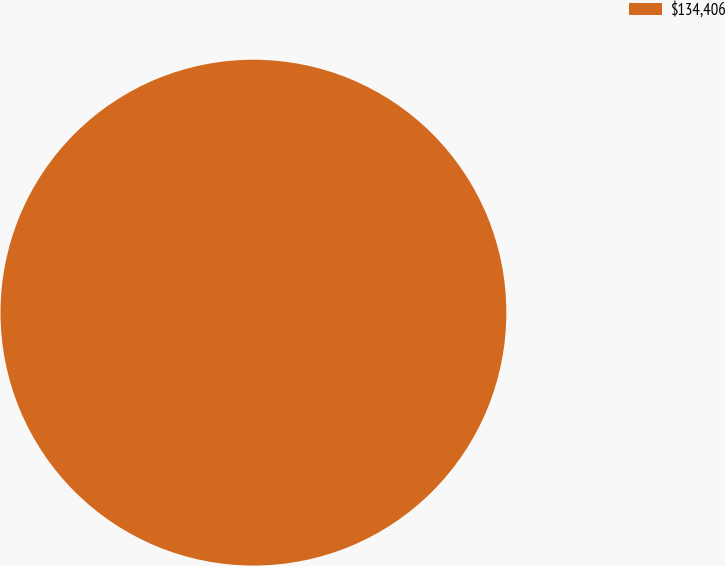<chart> <loc_0><loc_0><loc_500><loc_500><pie_chart><fcel>$134,406<nl><fcel>100.0%<nl></chart> 